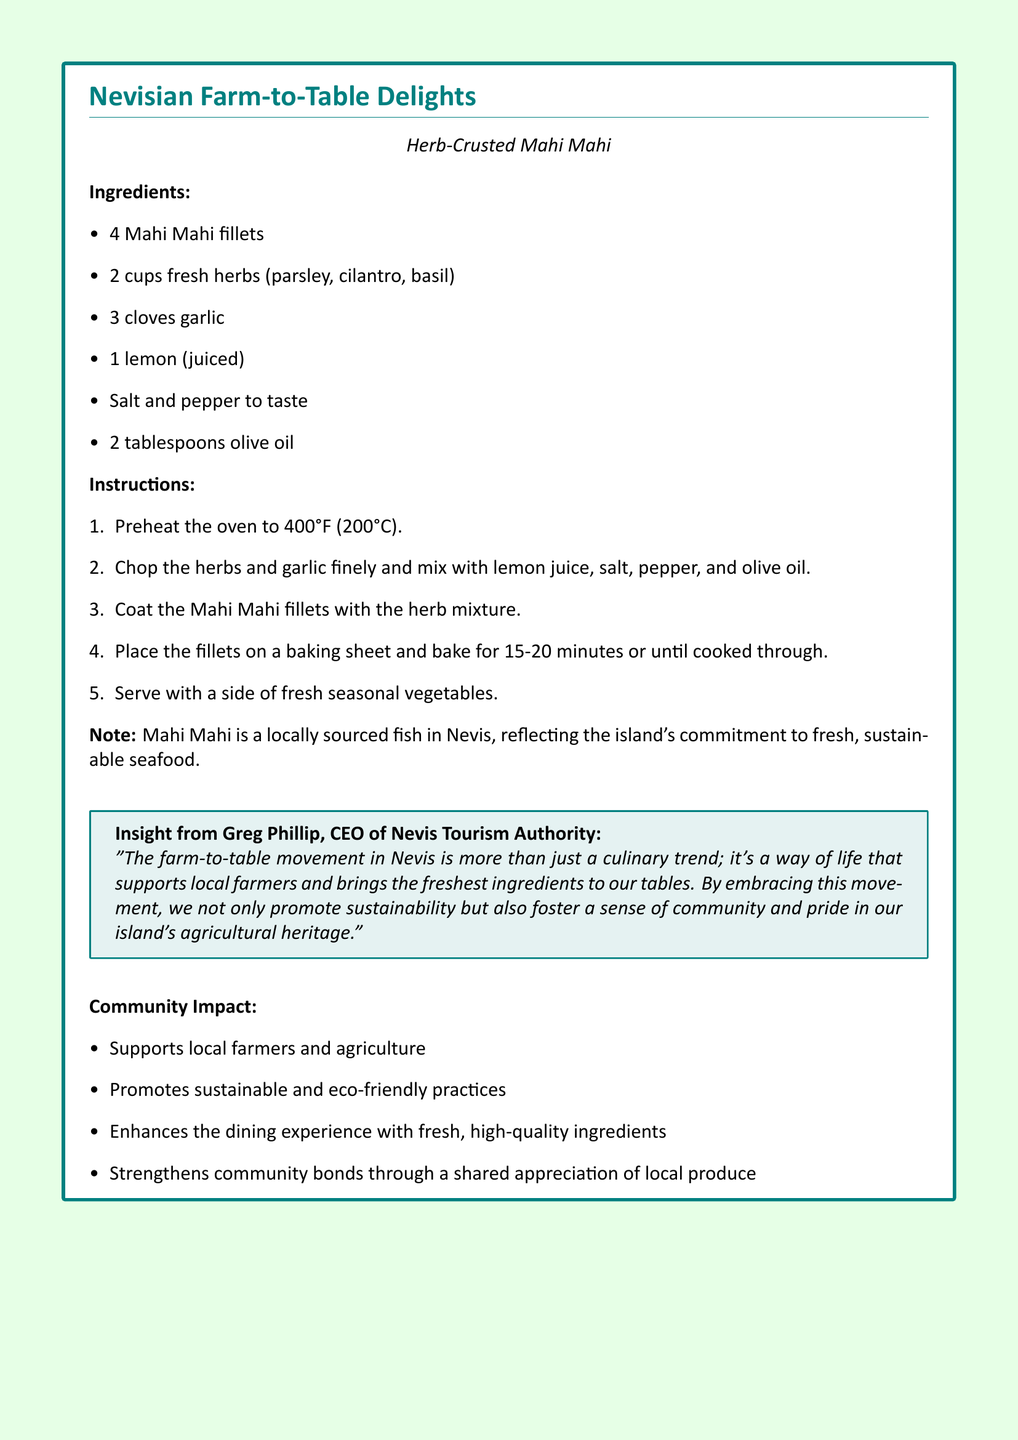What is the title of the recipe? The title of the recipe is prominently featured at the top of the document in bold text.
Answer: Nevisian Farm-to-Table Delights What type of fish is used in the recipe? The specific type of fish used in the recipe is mentioned in the title and the ingredients section.
Answer: Mahi Mahi How many Mahi Mahi fillets are needed? The ingredients list clearly states the quantity of Mahi Mahi fillets required for the recipe.
Answer: 4 What is the cooking temperature specified? The instructions section specifies the temperature to preheat the oven for baking.
Answer: 400°F Who provided insights about the farm-to-table movement? The insights section attributes the quote about the farm-to-table movement to a specific person.
Answer: Greg Phillip What does the farm-to-table movement support in the community? The community impact section lists the various benefits of the farm-to-table movement, highlighting its role in supporting local initiatives.
Answer: Local farmers and agriculture How long should the Mahi Mahi fillets be baked? The instructions section indicates the cooking time for the Mahi Mahi fillets.
Answer: 15-20 minutes What are the qualities of ingredients emphasized in the document? There is a mention of qualities in both the note and the community impact sections.
Answer: Fresh, high-quality ingredients 